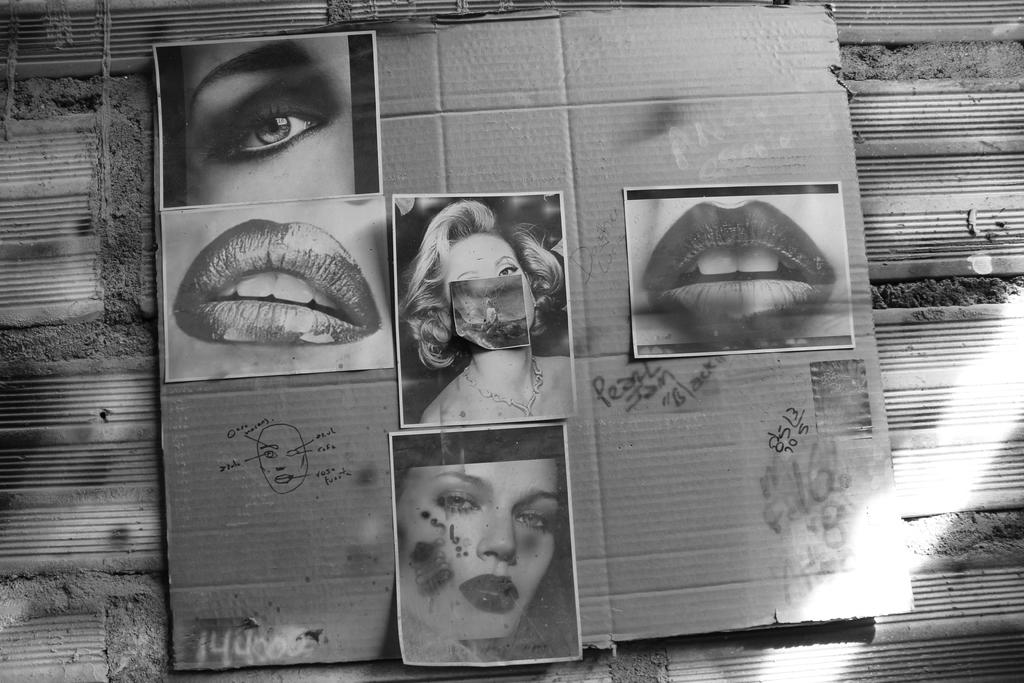What is the main object in the image? There is a cardboard in the image. Where is the cardboard located? The cardboard is on a surface. What images are present on the cardboard? There is a picture of lips, a picture of an eye, and pictures of two women on the cardboard. How many clocks are visible on the cardboard in the image? There are no clocks visible on the cardboard in the image. 